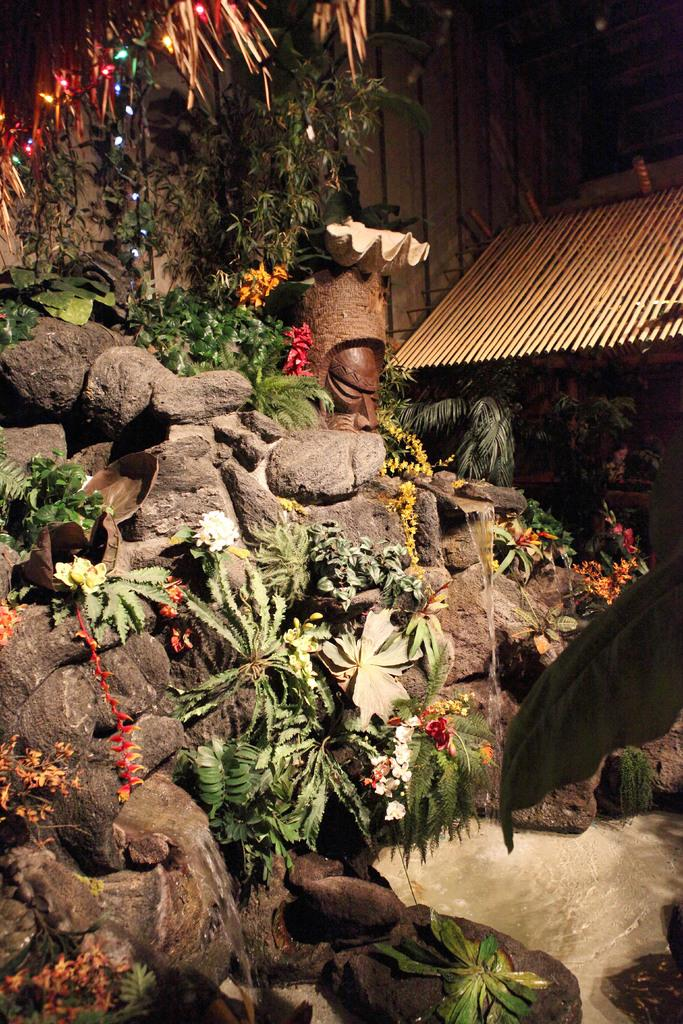What type of natural elements can be seen in the image? There are stones, plants, flowers, and water visible in the image. What man-made object is present in the image? There is a sculpture in the image. What type of lighting is present in the image? There are lights in the image. What other objects can be seen in the image? There are sticks and some unspecified objects in the image. What type of action are the snails performing in the image? There are no snails present in the image, so no action involving snails can be observed. Where is the lunchroom located in the image? There is no mention of a lunchroom in the image, so its location cannot be determined. 